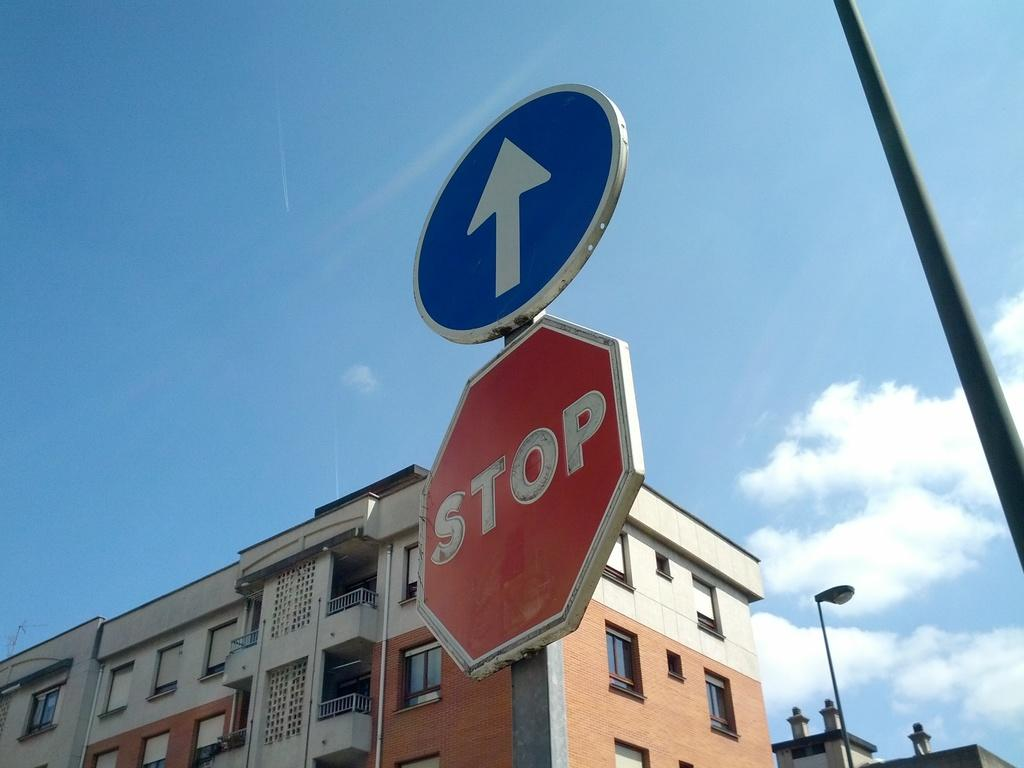<image>
Describe the image concisely. a stop sign with a white arrow above it 